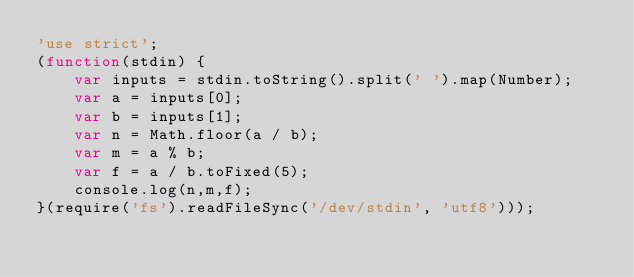<code> <loc_0><loc_0><loc_500><loc_500><_JavaScript_>'use strict';
(function(stdin) {
    var inputs = stdin.toString().split(' ').map(Number);
    var a = inputs[0];
    var b = inputs[1];
    var n = Math.floor(a / b);
    var m = a % b;
    var f = a / b.toFixed(5);
    console.log(n,m,f);
}(require('fs').readFileSync('/dev/stdin', 'utf8')));</code> 